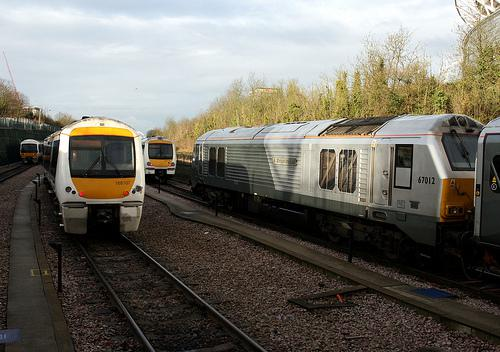Question: how many trains are in the photo?
Choices:
A. Three.
B. Two.
C. One.
D. Four.
Answer with the letter. Answer: D Question: where is this scene taking place?
Choices:
A. Near the subway.
B. Near the train tracks.
C. Near the mine.
D. Near the trolley stop.
Answer with the letter. Answer: B Question: what vehicle is shown in this photo?
Choices:
A. Trains.
B. Cars.
C. Buses.
D. Airplanes.
Answer with the letter. Answer: A Question: what are the trains travelling on?
Choices:
A. A bridge.
B. Gravel.
C. Train tracks.
D. A mountain.
Answer with the letter. Answer: C Question: what color is the train in the middle of the photo?
Choices:
A. Red and white.
B. Yellow and silver.
C. Orange and Blue.
D. Black and gold.
Answer with the letter. Answer: B Question: how many red lights are on on the front of the train in the middle of the photo?
Choices:
A. Three.
B. Two.
C. Four.
D. Five.
Answer with the letter. Answer: B 